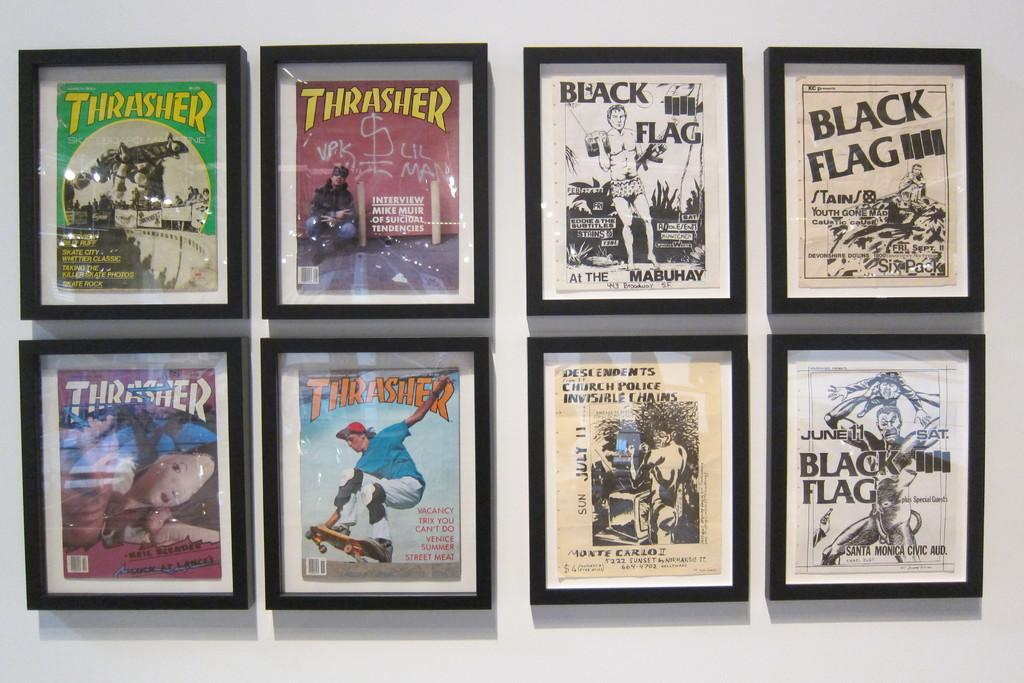<image>
Provide a brief description of the given image. Framed pictures of Thrasher images and Black Flag images. 